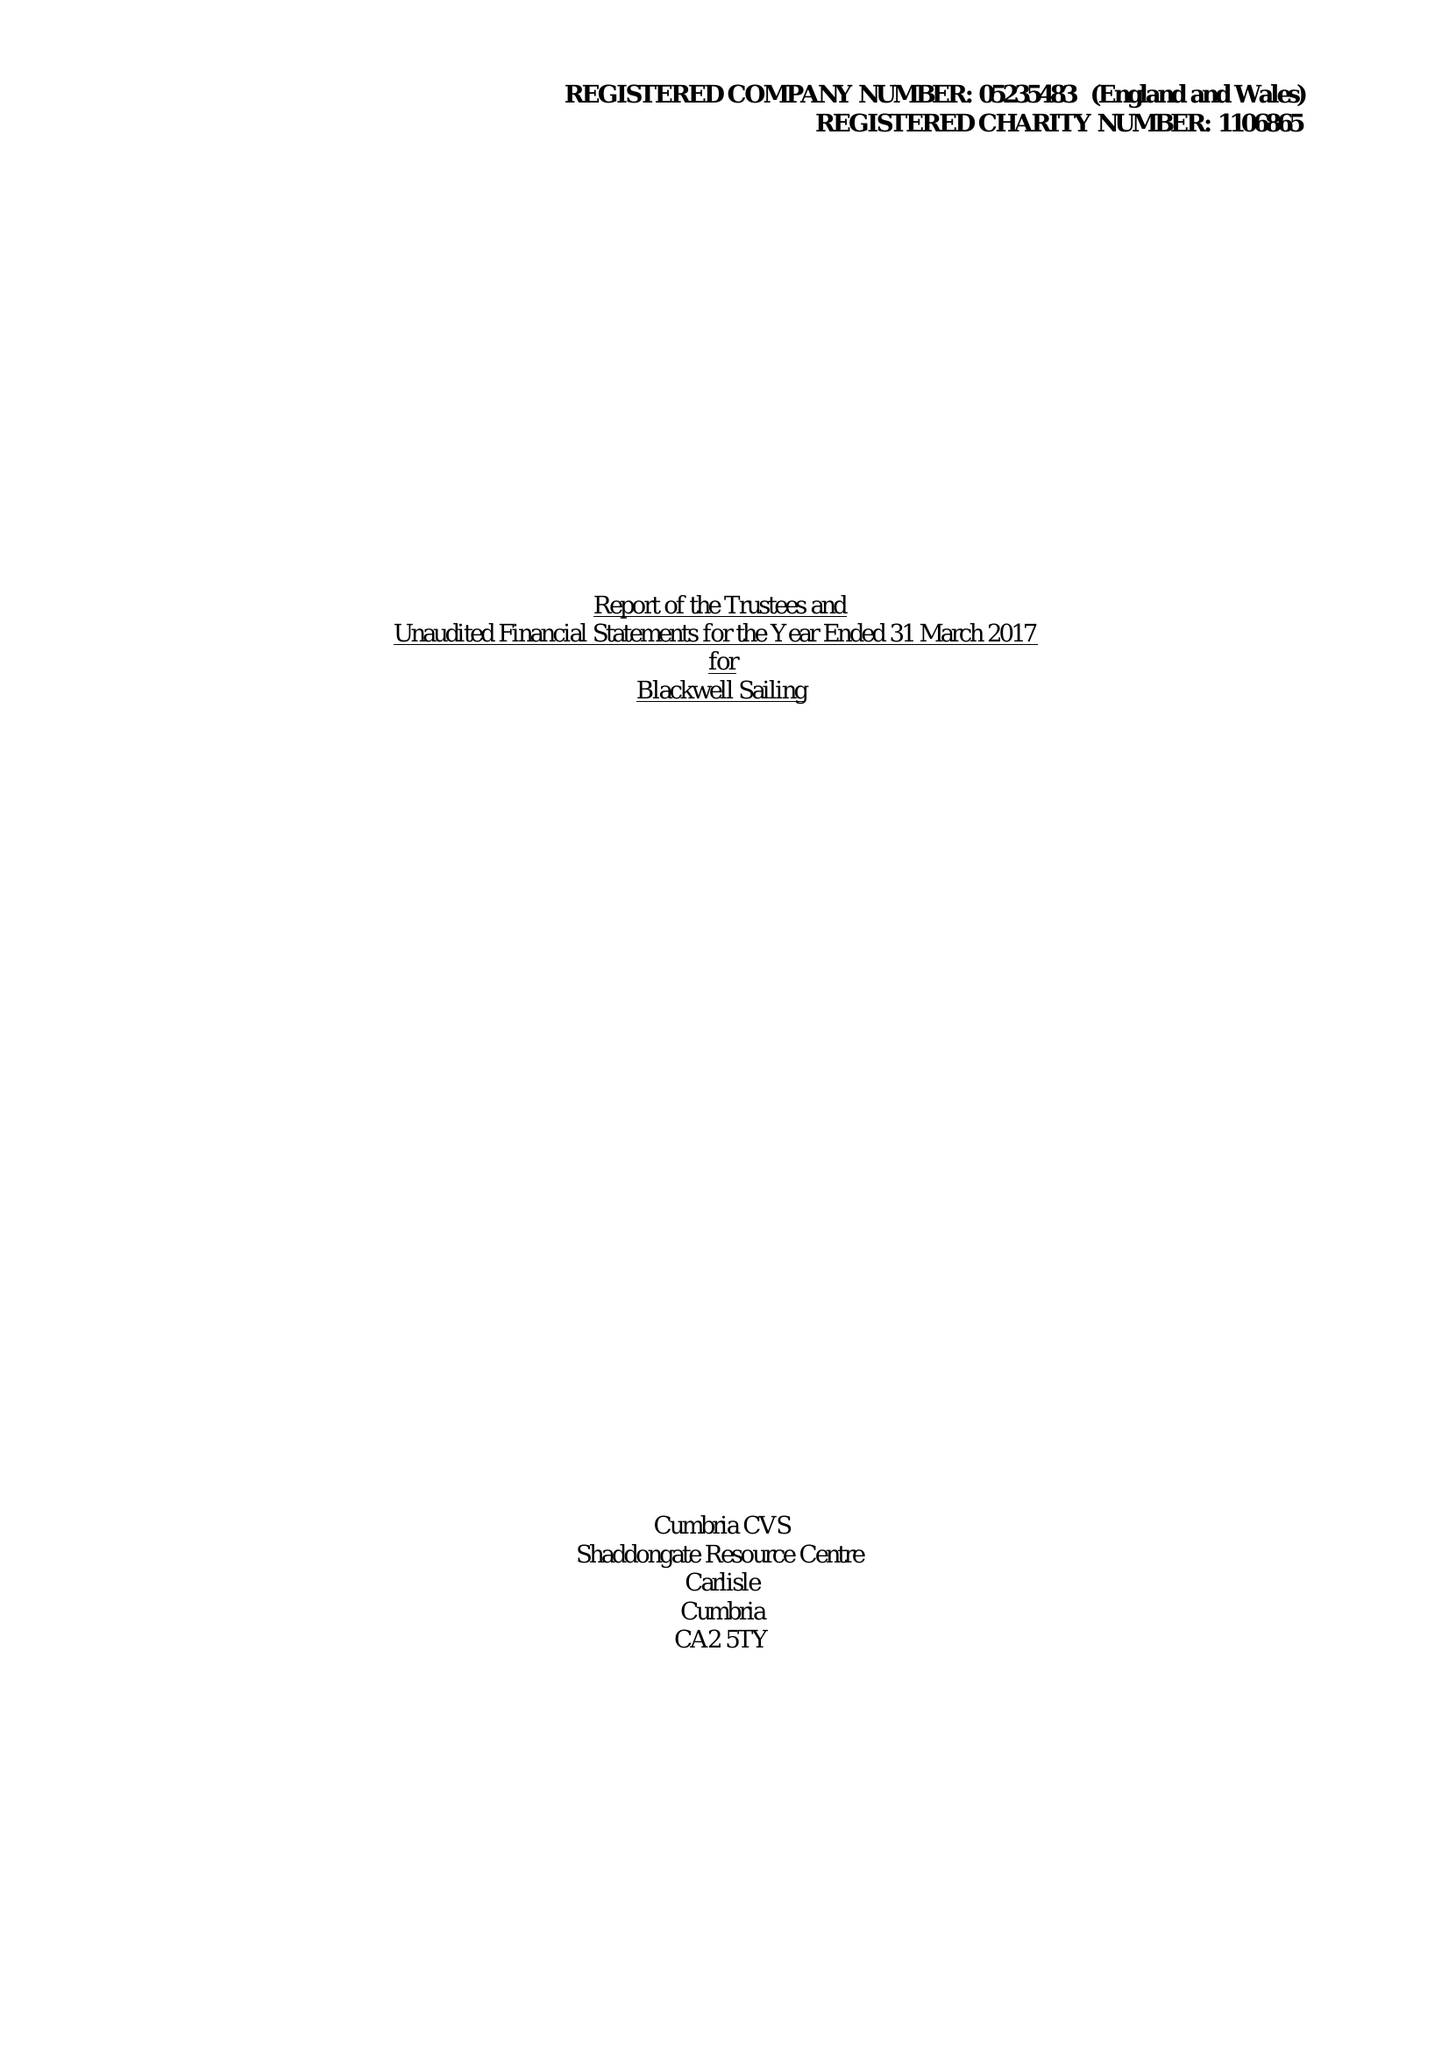What is the value for the report_date?
Answer the question using a single word or phrase. 2017-03-31 